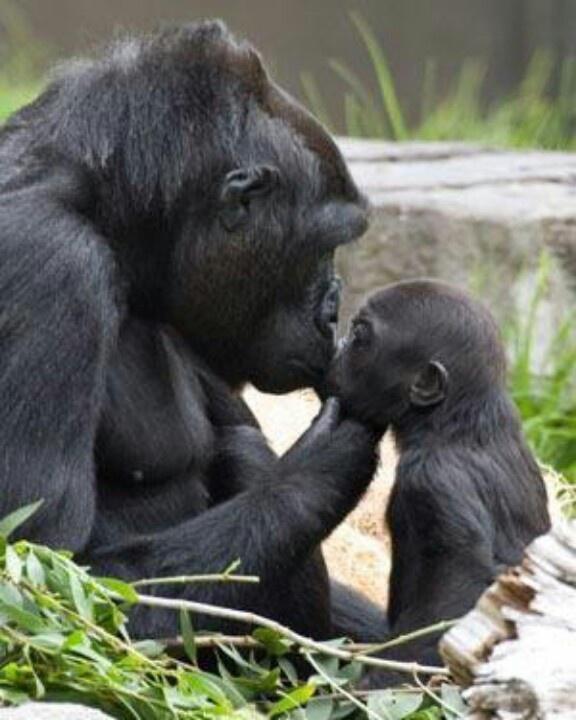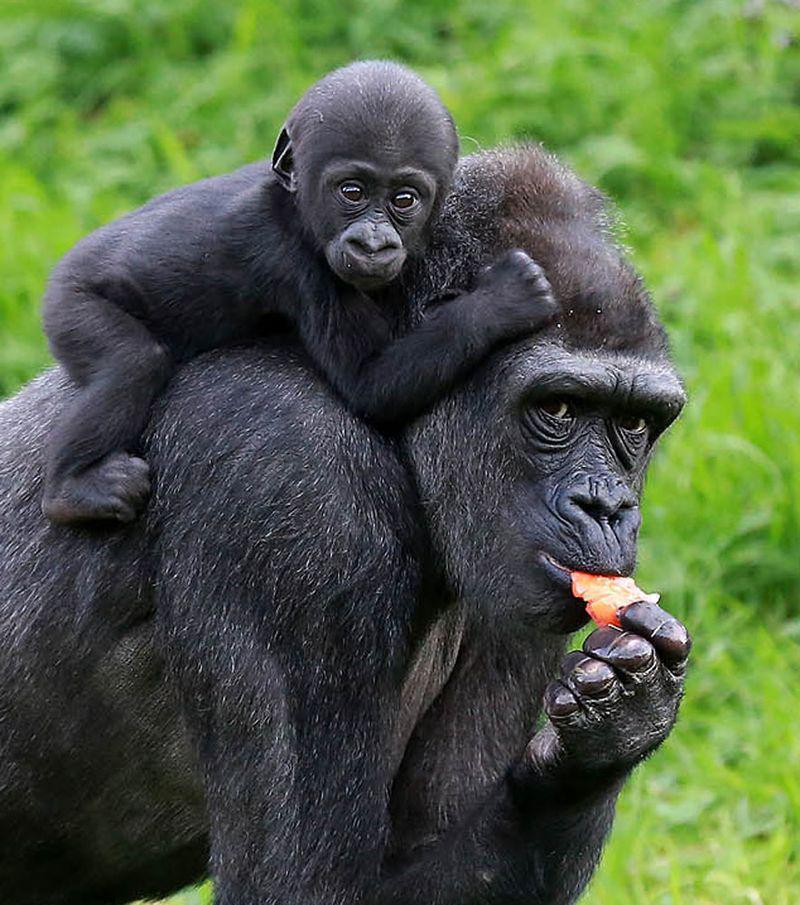The first image is the image on the left, the second image is the image on the right. Assess this claim about the two images: "An image shows a baby gorilla clinging on the back near the shoulders of an adult gorilla.". Correct or not? Answer yes or no. Yes. 